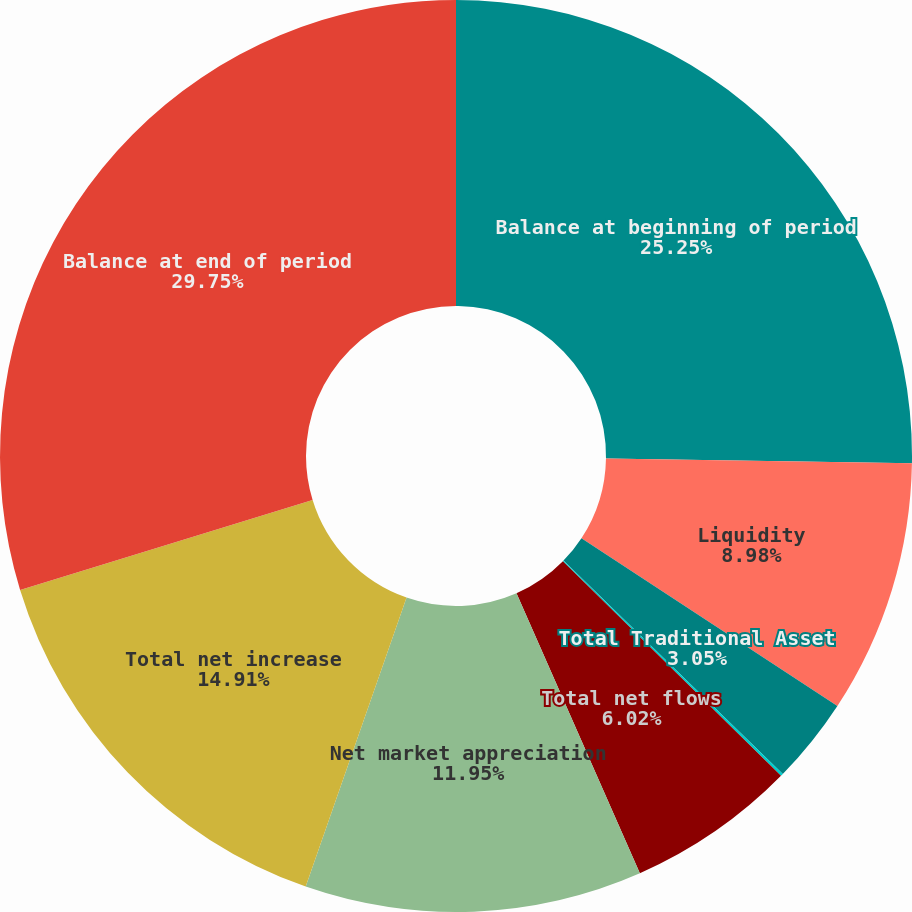<chart> <loc_0><loc_0><loc_500><loc_500><pie_chart><fcel>Balance at beginning of period<fcel>Liquidity<fcel>Total Traditional Asset<fcel>Real Estate Investing<fcel>Total net flows<fcel>Net market appreciation<fcel>Total net increase<fcel>Balance at end of period<nl><fcel>25.25%<fcel>8.98%<fcel>3.05%<fcel>0.09%<fcel>6.02%<fcel>11.95%<fcel>14.91%<fcel>29.74%<nl></chart> 